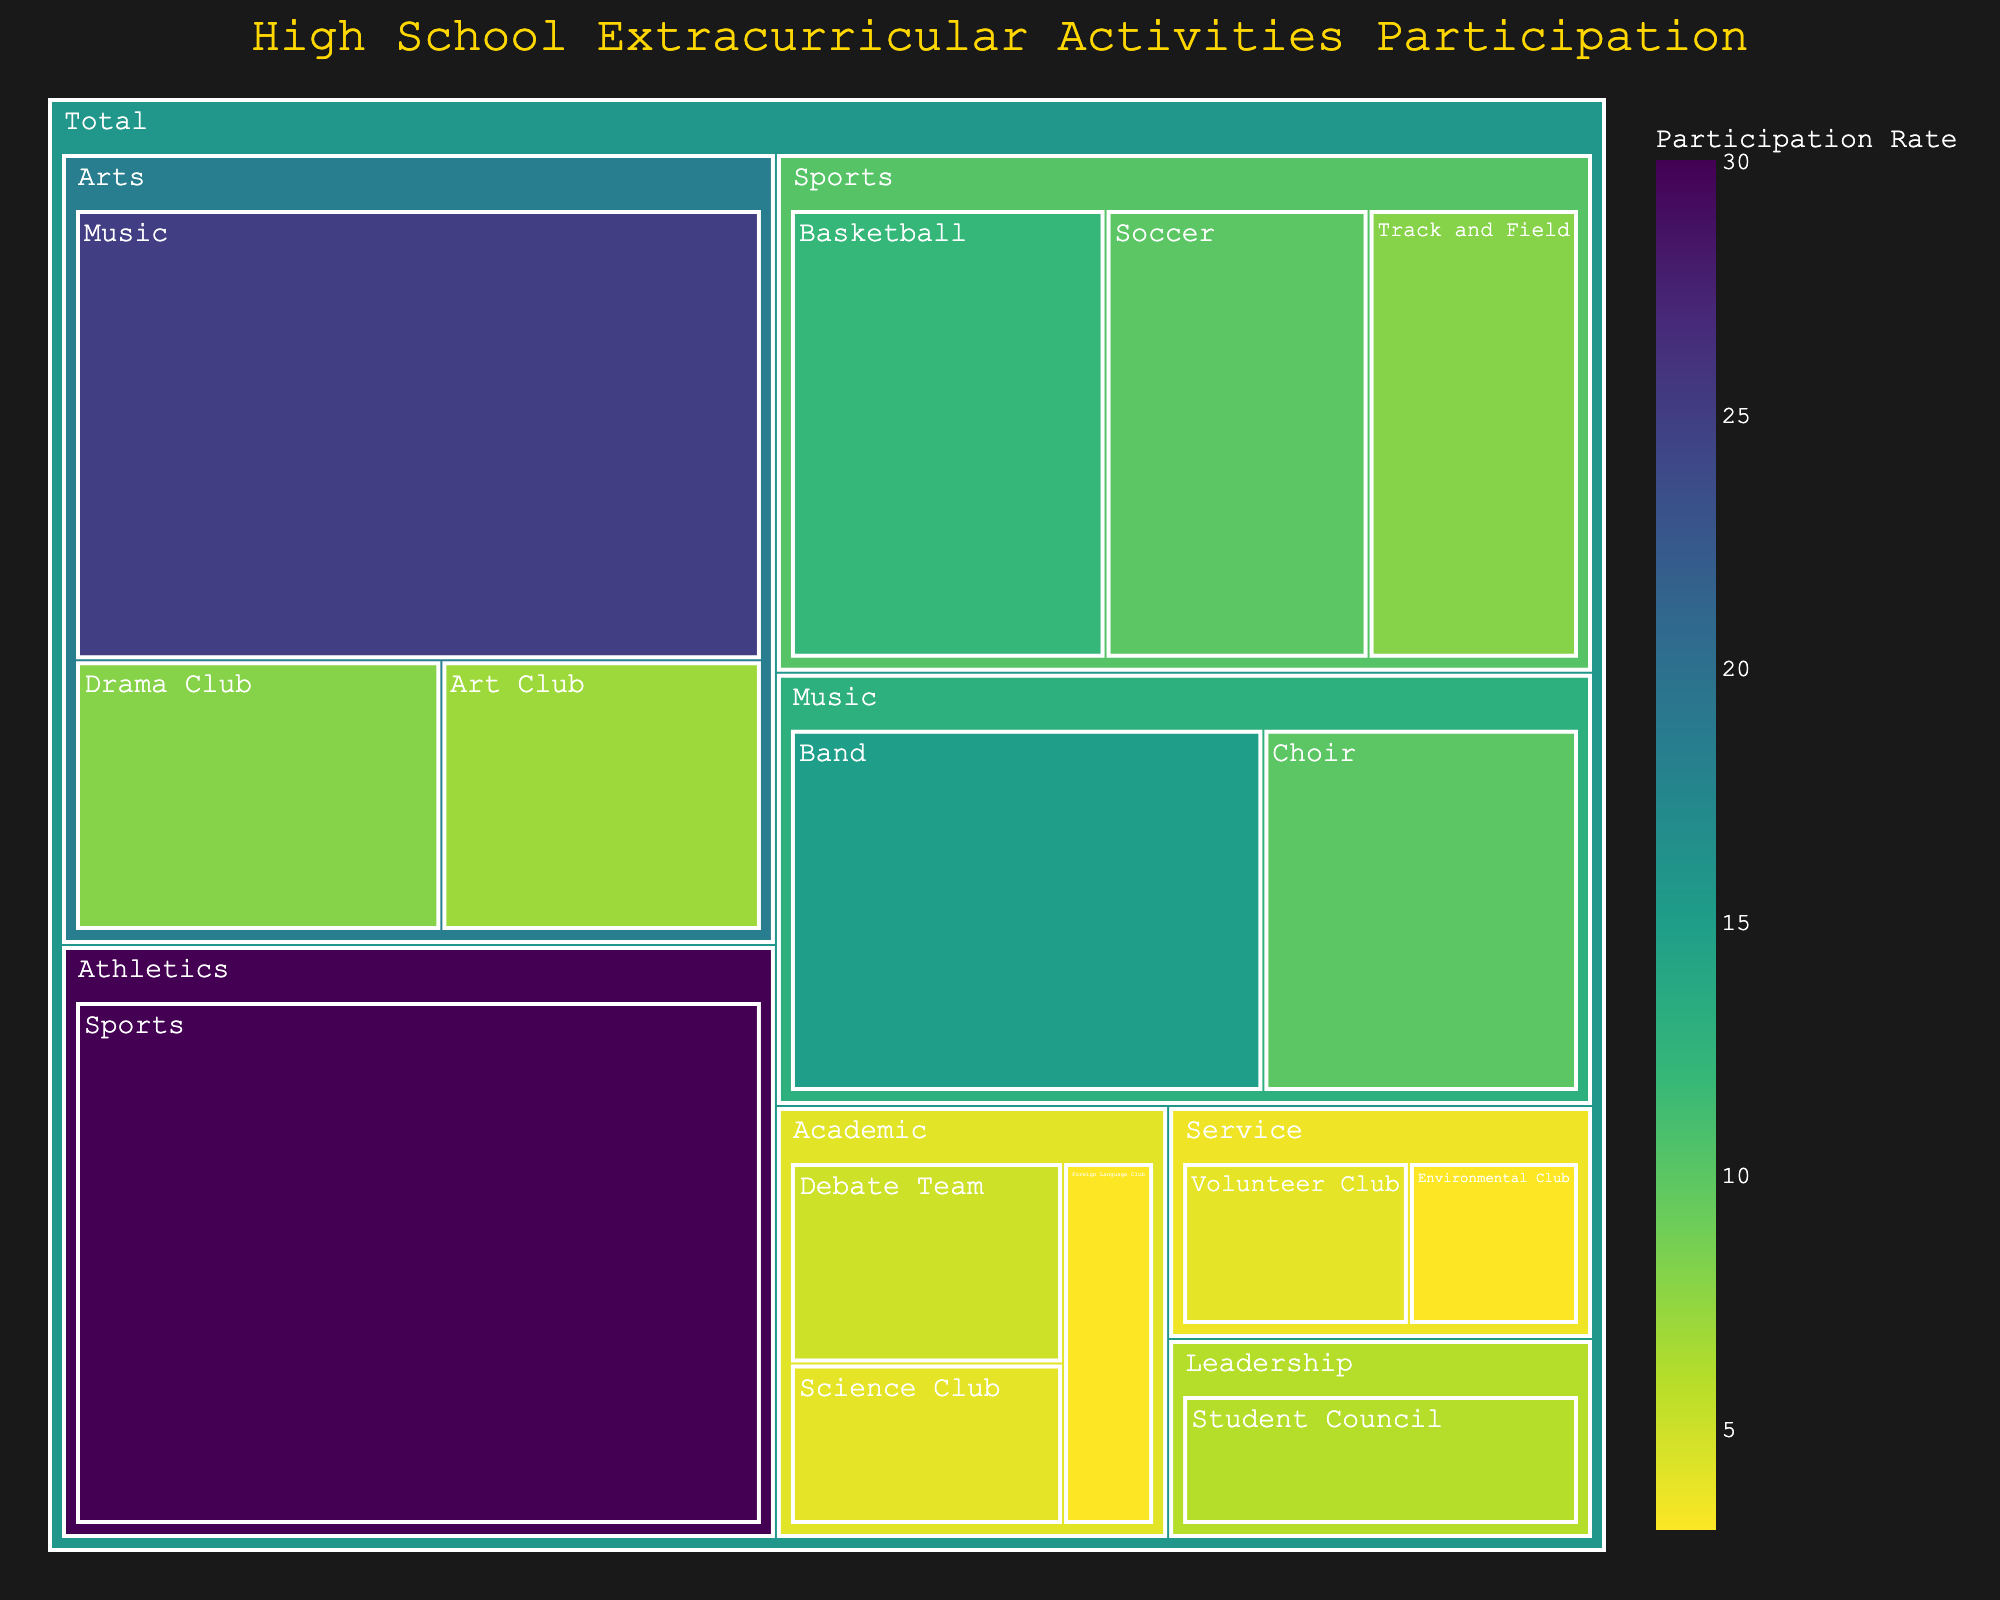What is the title of the treemap? The title is typically displayed at the top of the treemap in a larger and often differently colored font to highlight it. Observing the top section of the figure should clearly show the title.
Answer: High School Extracurricular Activities Participation Which category has the highest participation rate? Look at the segment size and the participation rate text within or around the segments. The category with the largest segment and potentially indicating the highest percentage is the correct answer.
Answer: Athletics What is the participation rate for the Band activity? Hover over or look at the Band segment in the Music category, and observe the participation rate displayed.
Answer: 15% Sum up the participation rates for all Sports activities. Find the participation rates for Basketball (12%), Soccer (10%), and Track and Field (8%) within the Sports category, then add them up: 12% + 10% + 8% = 30%.
Answer: 30% How does the participation rate of Choir compare to that of the Debate Team? Look at the segments for Choir under Music and Debate Team under Academic. Compare their values, which are 10% for Choir and 5% for Debate Team. Choir has a higher rate.
Answer: Choir has a higher rate (10% vs. 5%) What is the primary color scheme of the treemap? Observe the overall color palette used in the different segments. The dominant color scheme helps in differentiating categories and values.
Answer: Viridis What is the difference in participation rates between Soccer and Science Club? Find the participation rates for Soccer (10%) under Sports and Science Club (4%) under Academic. Subtract the lower value from the higher one: 10% - 4% = 6%.
Answer: 6% Which activity in the Service category has the higher participation rate, and what is it? Look at both Volunteer Club and Environmental Club segments under the Service category. Compare their participation rates, which are 4% and 3%, respectively. Volunteer Club has the higher rate.
Answer: Volunteer Club, 4% What is the average participation rate for the activities in the Leadership category? Locate the Leadership category, which includes only the Student Council activity with a participation rate of 6%. Since there is only one activity, the average is directly the participation rate: 6%.
Answer: 6% How are the activities grouped within the treemap? Observe the hierarchical structure where smaller segments fall under larger categories like Sports, Arts, etc. Each activity is visually nested within its respective category.
Answer: By category: Athletics, Sports, Arts, Leadership, Academic, Service 